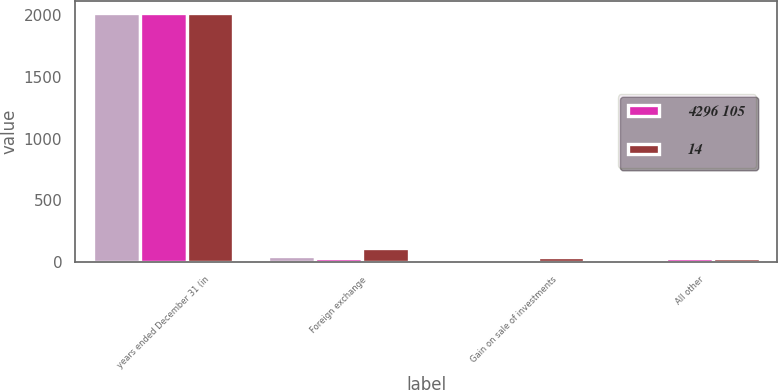Convert chart. <chart><loc_0><loc_0><loc_500><loc_500><stacked_bar_chart><ecel><fcel>years ended December 31 (in<fcel>Foreign exchange<fcel>Gain on sale of investments<fcel>All other<nl><fcel>nan<fcel>2017<fcel>50<fcel>3<fcel>6<nl><fcel>4296 105<fcel>2016<fcel>28<fcel>3<fcel>31<nl><fcel>14<fcel>2015<fcel>113<fcel>38<fcel>32<nl></chart> 